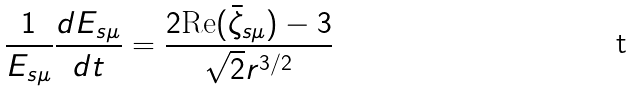<formula> <loc_0><loc_0><loc_500><loc_500>\frac { 1 } { E _ { s \mu } } \frac { d E _ { s \mu } } { d t } = \frac { 2 \text {Re} ( \bar { \zeta } _ { s \mu } ) - 3 } { \sqrt { 2 } r ^ { 3 / 2 } } \\</formula> 